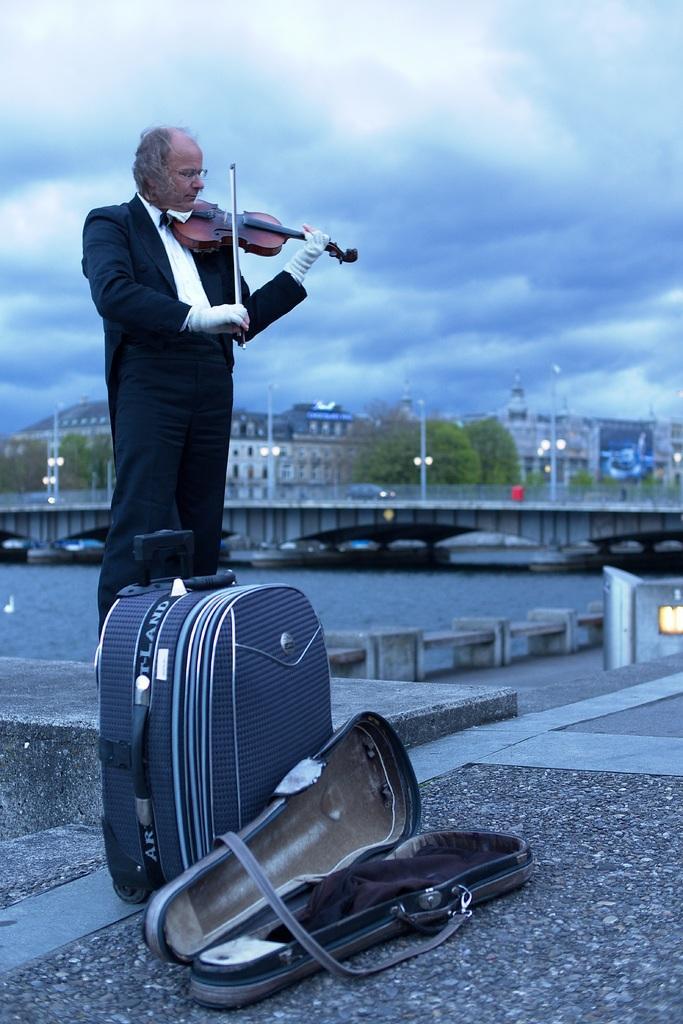Describe this image in one or two sentences. This person is holding a stick and violin. In-front of this person there is a violin bag and luggage. Far there are trees and buildings. Sky is cloudy. This is bridge. This is a freshwater river. 